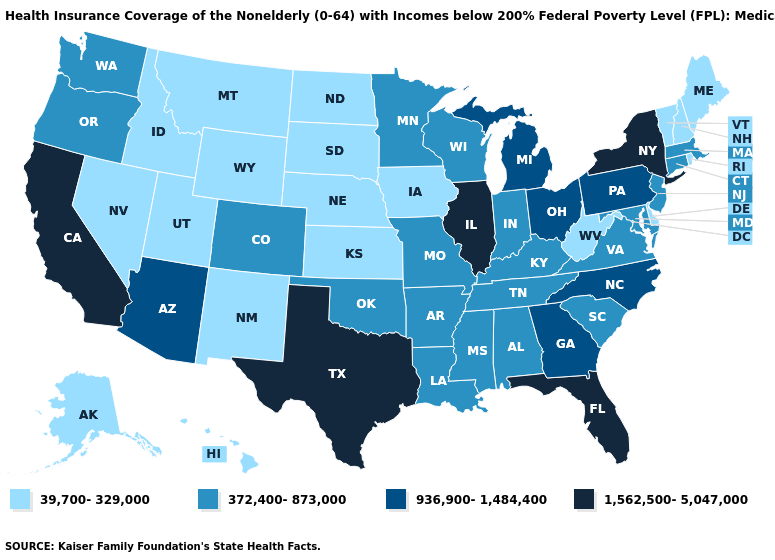What is the value of Nebraska?
Write a very short answer. 39,700-329,000. Does New Mexico have the same value as Michigan?
Be succinct. No. Name the states that have a value in the range 372,400-873,000?
Be succinct. Alabama, Arkansas, Colorado, Connecticut, Indiana, Kentucky, Louisiana, Maryland, Massachusetts, Minnesota, Mississippi, Missouri, New Jersey, Oklahoma, Oregon, South Carolina, Tennessee, Virginia, Washington, Wisconsin. Among the states that border Vermont , does Massachusetts have the highest value?
Keep it brief. No. Name the states that have a value in the range 1,562,500-5,047,000?
Give a very brief answer. California, Florida, Illinois, New York, Texas. What is the lowest value in states that border Connecticut?
Be succinct. 39,700-329,000. Does Connecticut have a lower value than Arizona?
Short answer required. Yes. Name the states that have a value in the range 1,562,500-5,047,000?
Concise answer only. California, Florida, Illinois, New York, Texas. Name the states that have a value in the range 1,562,500-5,047,000?
Write a very short answer. California, Florida, Illinois, New York, Texas. What is the value of Mississippi?
Be succinct. 372,400-873,000. Name the states that have a value in the range 1,562,500-5,047,000?
Give a very brief answer. California, Florida, Illinois, New York, Texas. What is the value of Virginia?
Be succinct. 372,400-873,000. Name the states that have a value in the range 1,562,500-5,047,000?
Keep it brief. California, Florida, Illinois, New York, Texas. What is the value of Washington?
Short answer required. 372,400-873,000. What is the lowest value in the USA?
Quick response, please. 39,700-329,000. 